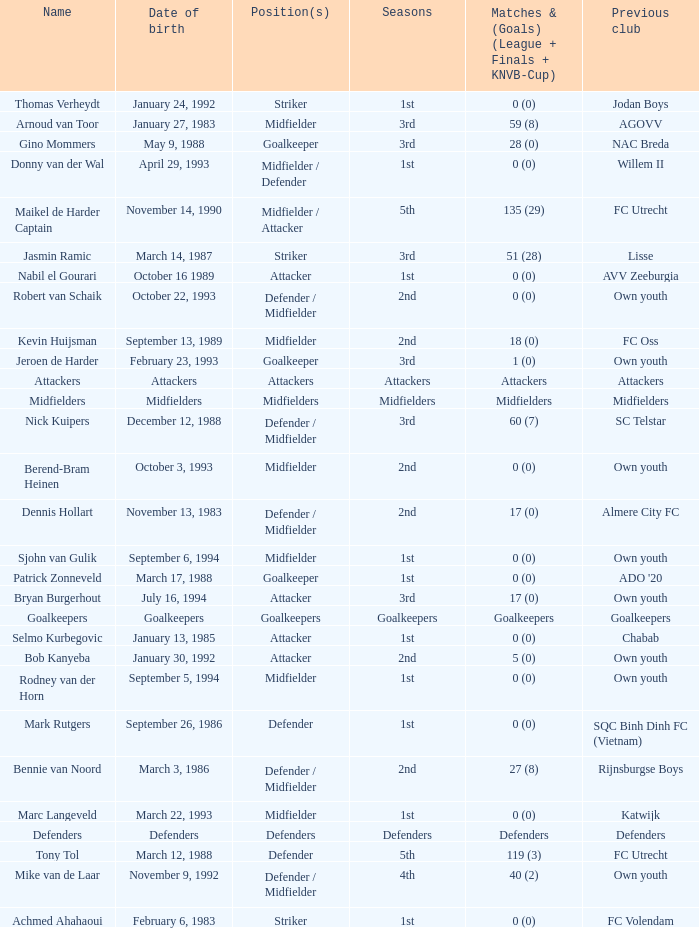What previous club was born on October 22, 1993? Own youth. 